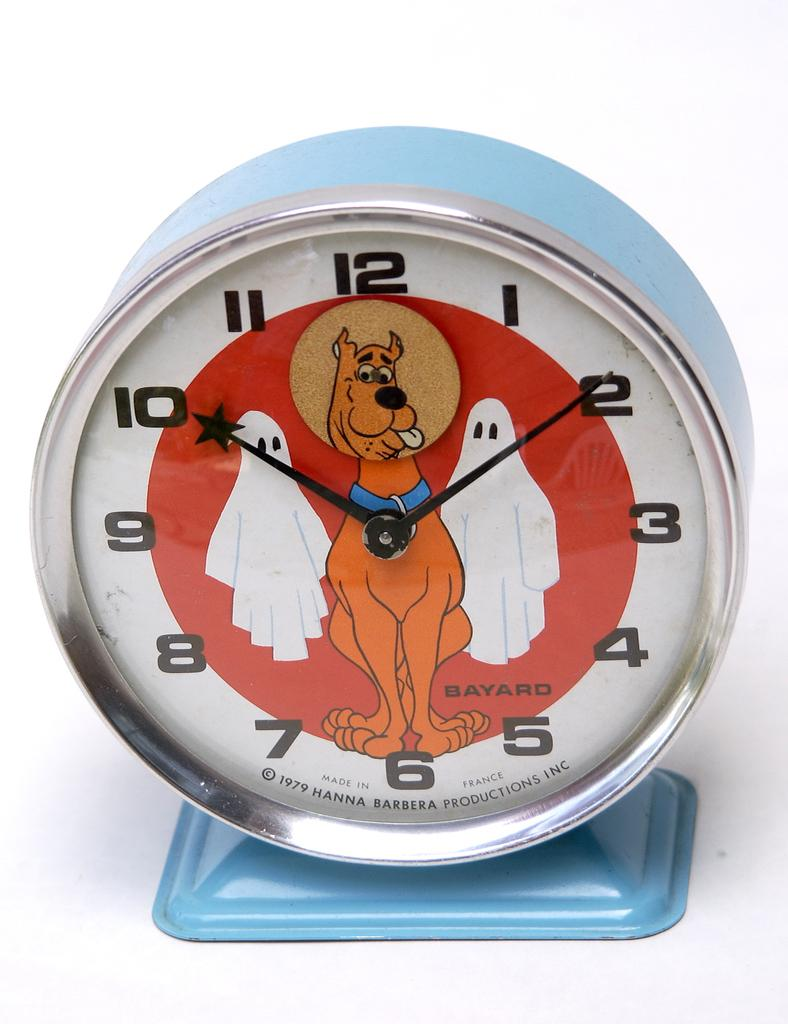<image>
Share a concise interpretation of the image provided. The alarm clock here is from the year 1979 